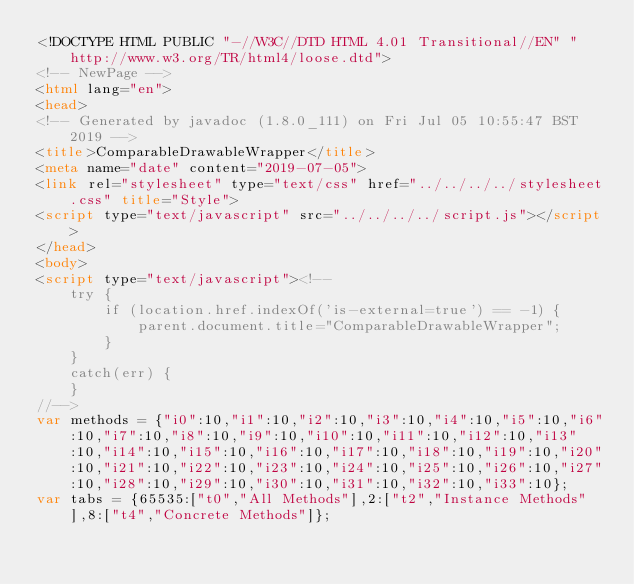Convert code to text. <code><loc_0><loc_0><loc_500><loc_500><_HTML_><!DOCTYPE HTML PUBLIC "-//W3C//DTD HTML 4.01 Transitional//EN" "http://www.w3.org/TR/html4/loose.dtd">
<!-- NewPage -->
<html lang="en">
<head>
<!-- Generated by javadoc (1.8.0_111) on Fri Jul 05 10:55:47 BST 2019 -->
<title>ComparableDrawableWrapper</title>
<meta name="date" content="2019-07-05">
<link rel="stylesheet" type="text/css" href="../../../../stylesheet.css" title="Style">
<script type="text/javascript" src="../../../../script.js"></script>
</head>
<body>
<script type="text/javascript"><!--
    try {
        if (location.href.indexOf('is-external=true') == -1) {
            parent.document.title="ComparableDrawableWrapper";
        }
    }
    catch(err) {
    }
//-->
var methods = {"i0":10,"i1":10,"i2":10,"i3":10,"i4":10,"i5":10,"i6":10,"i7":10,"i8":10,"i9":10,"i10":10,"i11":10,"i12":10,"i13":10,"i14":10,"i15":10,"i16":10,"i17":10,"i18":10,"i19":10,"i20":10,"i21":10,"i22":10,"i23":10,"i24":10,"i25":10,"i26":10,"i27":10,"i28":10,"i29":10,"i30":10,"i31":10,"i32":10,"i33":10};
var tabs = {65535:["t0","All Methods"],2:["t2","Instance Methods"],8:["t4","Concrete Methods"]};</code> 